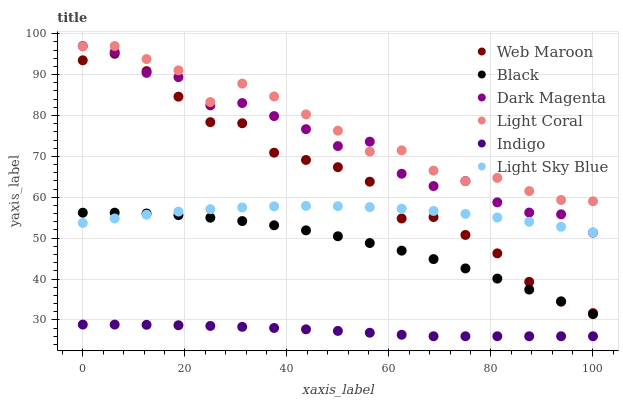Does Indigo have the minimum area under the curve?
Answer yes or no. Yes. Does Light Coral have the maximum area under the curve?
Answer yes or no. Yes. Does Dark Magenta have the minimum area under the curve?
Answer yes or no. No. Does Dark Magenta have the maximum area under the curve?
Answer yes or no. No. Is Indigo the smoothest?
Answer yes or no. Yes. Is Dark Magenta the roughest?
Answer yes or no. Yes. Is Web Maroon the smoothest?
Answer yes or no. No. Is Web Maroon the roughest?
Answer yes or no. No. Does Indigo have the lowest value?
Answer yes or no. Yes. Does Dark Magenta have the lowest value?
Answer yes or no. No. Does Light Coral have the highest value?
Answer yes or no. Yes. Does Web Maroon have the highest value?
Answer yes or no. No. Is Black less than Dark Magenta?
Answer yes or no. Yes. Is Light Coral greater than Light Sky Blue?
Answer yes or no. Yes. Does Light Sky Blue intersect Dark Magenta?
Answer yes or no. Yes. Is Light Sky Blue less than Dark Magenta?
Answer yes or no. No. Is Light Sky Blue greater than Dark Magenta?
Answer yes or no. No. Does Black intersect Dark Magenta?
Answer yes or no. No. 